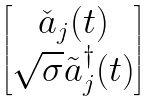<formula> <loc_0><loc_0><loc_500><loc_500>\begin{bmatrix} { \check { a } } _ { j } ( t ) \\ \sqrt { \sigma } { \tilde { a } } _ { j } ^ { \dagger } ( t ) \end{bmatrix}</formula> 